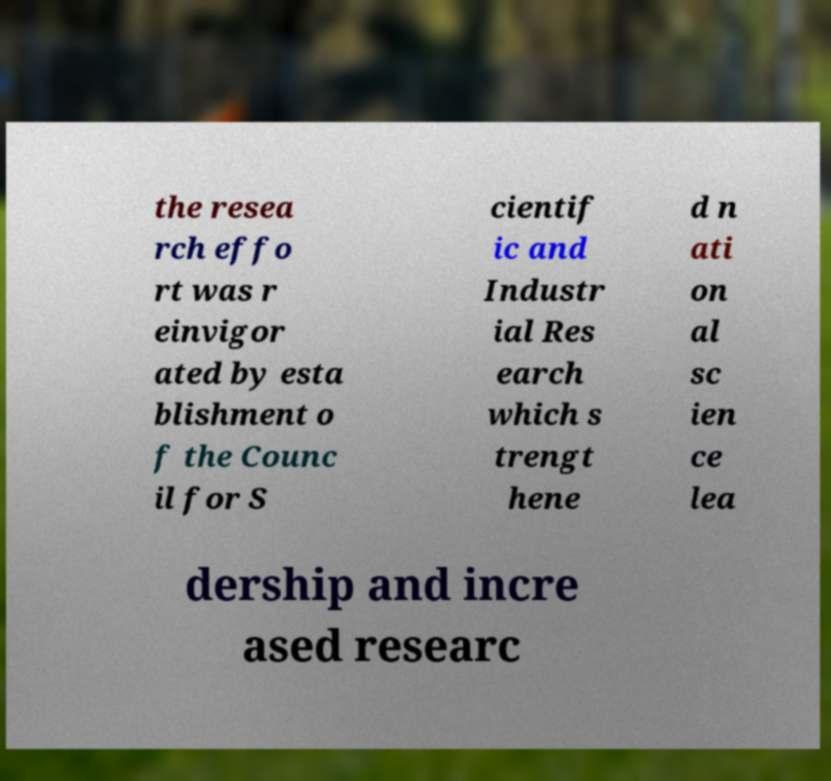Can you read and provide the text displayed in the image?This photo seems to have some interesting text. Can you extract and type it out for me? the resea rch effo rt was r einvigor ated by esta blishment o f the Counc il for S cientif ic and Industr ial Res earch which s trengt hene d n ati on al sc ien ce lea dership and incre ased researc 